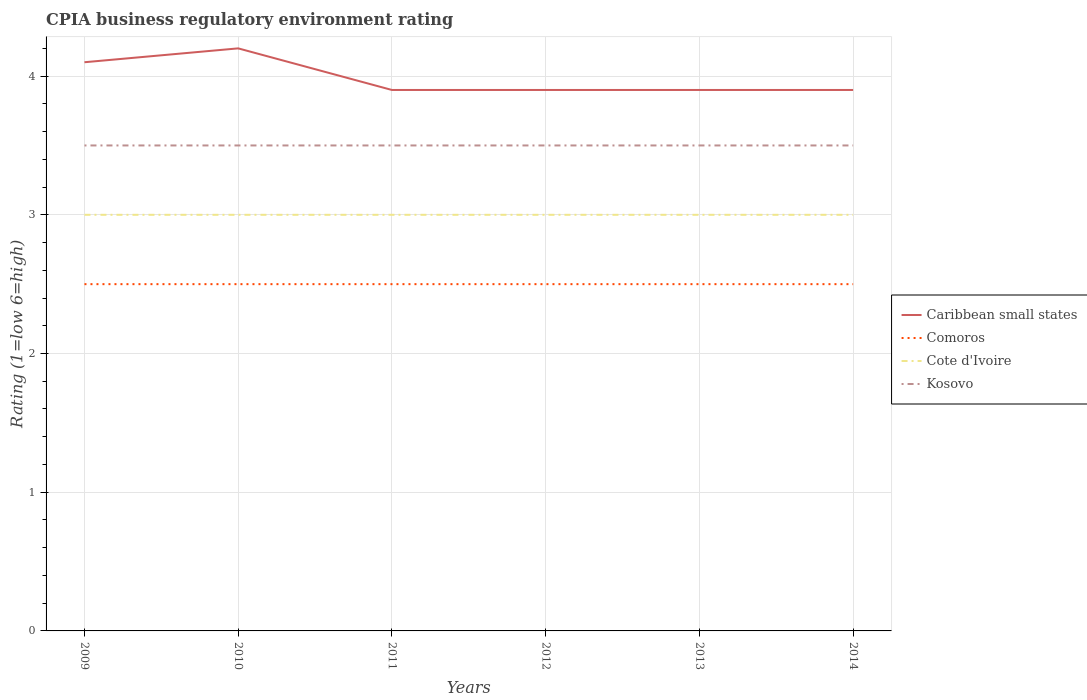Does the line corresponding to Kosovo intersect with the line corresponding to Caribbean small states?
Your response must be concise. No. Across all years, what is the maximum CPIA rating in Comoros?
Offer a terse response. 2.5. In which year was the CPIA rating in Kosovo maximum?
Your answer should be very brief. 2009. What is the difference between the highest and the lowest CPIA rating in Caribbean small states?
Your response must be concise. 2. How many lines are there?
Your answer should be very brief. 4. How many years are there in the graph?
Ensure brevity in your answer.  6. What is the difference between two consecutive major ticks on the Y-axis?
Give a very brief answer. 1. Does the graph contain any zero values?
Your answer should be very brief. No. How many legend labels are there?
Offer a very short reply. 4. What is the title of the graph?
Ensure brevity in your answer.  CPIA business regulatory environment rating. What is the Rating (1=low 6=high) of Cote d'Ivoire in 2009?
Your answer should be very brief. 3. What is the Rating (1=low 6=high) in Comoros in 2010?
Your answer should be compact. 2.5. What is the Rating (1=low 6=high) in Cote d'Ivoire in 2010?
Provide a succinct answer. 3. What is the Rating (1=low 6=high) in Caribbean small states in 2011?
Offer a very short reply. 3.9. What is the Rating (1=low 6=high) in Kosovo in 2011?
Ensure brevity in your answer.  3.5. What is the Rating (1=low 6=high) of Caribbean small states in 2012?
Offer a very short reply. 3.9. What is the Rating (1=low 6=high) in Comoros in 2012?
Give a very brief answer. 2.5. What is the Rating (1=low 6=high) of Kosovo in 2012?
Your answer should be compact. 3.5. What is the Rating (1=low 6=high) in Cote d'Ivoire in 2013?
Offer a very short reply. 3. What is the Rating (1=low 6=high) of Comoros in 2014?
Keep it short and to the point. 2.5. Across all years, what is the maximum Rating (1=low 6=high) in Caribbean small states?
Provide a succinct answer. 4.2. Across all years, what is the maximum Rating (1=low 6=high) in Comoros?
Provide a short and direct response. 2.5. Across all years, what is the maximum Rating (1=low 6=high) in Cote d'Ivoire?
Offer a terse response. 3. Across all years, what is the minimum Rating (1=low 6=high) in Caribbean small states?
Keep it short and to the point. 3.9. Across all years, what is the minimum Rating (1=low 6=high) of Comoros?
Your answer should be compact. 2.5. What is the total Rating (1=low 6=high) in Caribbean small states in the graph?
Your answer should be compact. 23.9. What is the total Rating (1=low 6=high) in Kosovo in the graph?
Ensure brevity in your answer.  21. What is the difference between the Rating (1=low 6=high) of Caribbean small states in 2009 and that in 2010?
Offer a very short reply. -0.1. What is the difference between the Rating (1=low 6=high) of Comoros in 2009 and that in 2010?
Ensure brevity in your answer.  0. What is the difference between the Rating (1=low 6=high) in Cote d'Ivoire in 2009 and that in 2010?
Your answer should be very brief. 0. What is the difference between the Rating (1=low 6=high) in Kosovo in 2009 and that in 2010?
Make the answer very short. 0. What is the difference between the Rating (1=low 6=high) in Cote d'Ivoire in 2009 and that in 2011?
Provide a short and direct response. 0. What is the difference between the Rating (1=low 6=high) of Kosovo in 2009 and that in 2011?
Keep it short and to the point. 0. What is the difference between the Rating (1=low 6=high) in Caribbean small states in 2009 and that in 2012?
Keep it short and to the point. 0.2. What is the difference between the Rating (1=low 6=high) in Cote d'Ivoire in 2009 and that in 2012?
Your response must be concise. 0. What is the difference between the Rating (1=low 6=high) in Caribbean small states in 2009 and that in 2014?
Make the answer very short. 0.2. What is the difference between the Rating (1=low 6=high) in Cote d'Ivoire in 2009 and that in 2014?
Your answer should be compact. 0. What is the difference between the Rating (1=low 6=high) in Cote d'Ivoire in 2010 and that in 2011?
Provide a short and direct response. 0. What is the difference between the Rating (1=low 6=high) in Kosovo in 2010 and that in 2011?
Your answer should be compact. 0. What is the difference between the Rating (1=low 6=high) in Caribbean small states in 2010 and that in 2012?
Your answer should be compact. 0.3. What is the difference between the Rating (1=low 6=high) of Comoros in 2010 and that in 2012?
Make the answer very short. 0. What is the difference between the Rating (1=low 6=high) of Cote d'Ivoire in 2010 and that in 2013?
Give a very brief answer. 0. What is the difference between the Rating (1=low 6=high) of Kosovo in 2010 and that in 2013?
Give a very brief answer. 0. What is the difference between the Rating (1=low 6=high) of Comoros in 2010 and that in 2014?
Provide a short and direct response. 0. What is the difference between the Rating (1=low 6=high) of Cote d'Ivoire in 2010 and that in 2014?
Offer a very short reply. 0. What is the difference between the Rating (1=low 6=high) of Kosovo in 2010 and that in 2014?
Your answer should be very brief. 0. What is the difference between the Rating (1=low 6=high) of Caribbean small states in 2011 and that in 2012?
Your answer should be very brief. 0. What is the difference between the Rating (1=low 6=high) in Cote d'Ivoire in 2011 and that in 2012?
Your answer should be very brief. 0. What is the difference between the Rating (1=low 6=high) of Kosovo in 2011 and that in 2012?
Offer a terse response. 0. What is the difference between the Rating (1=low 6=high) of Comoros in 2011 and that in 2013?
Ensure brevity in your answer.  0. What is the difference between the Rating (1=low 6=high) in Caribbean small states in 2011 and that in 2014?
Give a very brief answer. 0. What is the difference between the Rating (1=low 6=high) in Cote d'Ivoire in 2011 and that in 2014?
Provide a short and direct response. 0. What is the difference between the Rating (1=low 6=high) of Kosovo in 2011 and that in 2014?
Offer a terse response. 0. What is the difference between the Rating (1=low 6=high) of Cote d'Ivoire in 2012 and that in 2013?
Keep it short and to the point. 0. What is the difference between the Rating (1=low 6=high) of Kosovo in 2012 and that in 2013?
Ensure brevity in your answer.  0. What is the difference between the Rating (1=low 6=high) of Caribbean small states in 2012 and that in 2014?
Provide a succinct answer. 0. What is the difference between the Rating (1=low 6=high) of Cote d'Ivoire in 2012 and that in 2014?
Ensure brevity in your answer.  0. What is the difference between the Rating (1=low 6=high) of Kosovo in 2012 and that in 2014?
Your answer should be compact. 0. What is the difference between the Rating (1=low 6=high) of Caribbean small states in 2013 and that in 2014?
Give a very brief answer. 0. What is the difference between the Rating (1=low 6=high) of Comoros in 2013 and that in 2014?
Provide a succinct answer. 0. What is the difference between the Rating (1=low 6=high) of Cote d'Ivoire in 2013 and that in 2014?
Offer a terse response. 0. What is the difference between the Rating (1=low 6=high) of Caribbean small states in 2009 and the Rating (1=low 6=high) of Comoros in 2010?
Your answer should be compact. 1.6. What is the difference between the Rating (1=low 6=high) of Caribbean small states in 2009 and the Rating (1=low 6=high) of Cote d'Ivoire in 2010?
Offer a terse response. 1.1. What is the difference between the Rating (1=low 6=high) in Caribbean small states in 2009 and the Rating (1=low 6=high) in Kosovo in 2010?
Make the answer very short. 0.6. What is the difference between the Rating (1=low 6=high) of Comoros in 2009 and the Rating (1=low 6=high) of Cote d'Ivoire in 2010?
Your answer should be compact. -0.5. What is the difference between the Rating (1=low 6=high) in Comoros in 2009 and the Rating (1=low 6=high) in Kosovo in 2010?
Offer a terse response. -1. What is the difference between the Rating (1=low 6=high) in Caribbean small states in 2009 and the Rating (1=low 6=high) in Comoros in 2011?
Provide a short and direct response. 1.6. What is the difference between the Rating (1=low 6=high) of Caribbean small states in 2009 and the Rating (1=low 6=high) of Cote d'Ivoire in 2011?
Make the answer very short. 1.1. What is the difference between the Rating (1=low 6=high) in Caribbean small states in 2009 and the Rating (1=low 6=high) in Kosovo in 2011?
Provide a short and direct response. 0.6. What is the difference between the Rating (1=low 6=high) of Comoros in 2009 and the Rating (1=low 6=high) of Cote d'Ivoire in 2011?
Your answer should be compact. -0.5. What is the difference between the Rating (1=low 6=high) of Comoros in 2009 and the Rating (1=low 6=high) of Kosovo in 2011?
Give a very brief answer. -1. What is the difference between the Rating (1=low 6=high) in Cote d'Ivoire in 2009 and the Rating (1=low 6=high) in Kosovo in 2011?
Provide a succinct answer. -0.5. What is the difference between the Rating (1=low 6=high) in Caribbean small states in 2009 and the Rating (1=low 6=high) in Comoros in 2012?
Ensure brevity in your answer.  1.6. What is the difference between the Rating (1=low 6=high) of Caribbean small states in 2009 and the Rating (1=low 6=high) of Cote d'Ivoire in 2012?
Provide a succinct answer. 1.1. What is the difference between the Rating (1=low 6=high) in Comoros in 2009 and the Rating (1=low 6=high) in Kosovo in 2012?
Ensure brevity in your answer.  -1. What is the difference between the Rating (1=low 6=high) of Caribbean small states in 2009 and the Rating (1=low 6=high) of Comoros in 2013?
Ensure brevity in your answer.  1.6. What is the difference between the Rating (1=low 6=high) in Caribbean small states in 2009 and the Rating (1=low 6=high) in Cote d'Ivoire in 2013?
Provide a short and direct response. 1.1. What is the difference between the Rating (1=low 6=high) in Comoros in 2009 and the Rating (1=low 6=high) in Cote d'Ivoire in 2013?
Offer a very short reply. -0.5. What is the difference between the Rating (1=low 6=high) of Comoros in 2009 and the Rating (1=low 6=high) of Kosovo in 2013?
Keep it short and to the point. -1. What is the difference between the Rating (1=low 6=high) of Caribbean small states in 2009 and the Rating (1=low 6=high) of Comoros in 2014?
Your response must be concise. 1.6. What is the difference between the Rating (1=low 6=high) of Caribbean small states in 2009 and the Rating (1=low 6=high) of Kosovo in 2014?
Your answer should be very brief. 0.6. What is the difference between the Rating (1=low 6=high) of Comoros in 2009 and the Rating (1=low 6=high) of Cote d'Ivoire in 2014?
Your response must be concise. -0.5. What is the difference between the Rating (1=low 6=high) in Cote d'Ivoire in 2009 and the Rating (1=low 6=high) in Kosovo in 2014?
Offer a very short reply. -0.5. What is the difference between the Rating (1=low 6=high) of Caribbean small states in 2010 and the Rating (1=low 6=high) of Cote d'Ivoire in 2011?
Your response must be concise. 1.2. What is the difference between the Rating (1=low 6=high) of Caribbean small states in 2010 and the Rating (1=low 6=high) of Kosovo in 2011?
Offer a very short reply. 0.7. What is the difference between the Rating (1=low 6=high) in Comoros in 2010 and the Rating (1=low 6=high) in Cote d'Ivoire in 2011?
Make the answer very short. -0.5. What is the difference between the Rating (1=low 6=high) of Comoros in 2010 and the Rating (1=low 6=high) of Kosovo in 2011?
Your response must be concise. -1. What is the difference between the Rating (1=low 6=high) in Caribbean small states in 2010 and the Rating (1=low 6=high) in Comoros in 2012?
Your answer should be compact. 1.7. What is the difference between the Rating (1=low 6=high) of Caribbean small states in 2010 and the Rating (1=low 6=high) of Kosovo in 2012?
Make the answer very short. 0.7. What is the difference between the Rating (1=low 6=high) of Comoros in 2010 and the Rating (1=low 6=high) of Cote d'Ivoire in 2012?
Give a very brief answer. -0.5. What is the difference between the Rating (1=low 6=high) of Comoros in 2010 and the Rating (1=low 6=high) of Kosovo in 2012?
Your answer should be compact. -1. What is the difference between the Rating (1=low 6=high) of Caribbean small states in 2010 and the Rating (1=low 6=high) of Cote d'Ivoire in 2013?
Keep it short and to the point. 1.2. What is the difference between the Rating (1=low 6=high) in Comoros in 2010 and the Rating (1=low 6=high) in Cote d'Ivoire in 2013?
Make the answer very short. -0.5. What is the difference between the Rating (1=low 6=high) in Caribbean small states in 2010 and the Rating (1=low 6=high) in Cote d'Ivoire in 2014?
Ensure brevity in your answer.  1.2. What is the difference between the Rating (1=low 6=high) of Caribbean small states in 2011 and the Rating (1=low 6=high) of Comoros in 2012?
Make the answer very short. 1.4. What is the difference between the Rating (1=low 6=high) in Caribbean small states in 2011 and the Rating (1=low 6=high) in Cote d'Ivoire in 2012?
Provide a succinct answer. 0.9. What is the difference between the Rating (1=low 6=high) in Caribbean small states in 2011 and the Rating (1=low 6=high) in Kosovo in 2012?
Your answer should be compact. 0.4. What is the difference between the Rating (1=low 6=high) of Cote d'Ivoire in 2011 and the Rating (1=low 6=high) of Kosovo in 2012?
Provide a short and direct response. -0.5. What is the difference between the Rating (1=low 6=high) of Caribbean small states in 2011 and the Rating (1=low 6=high) of Kosovo in 2013?
Give a very brief answer. 0.4. What is the difference between the Rating (1=low 6=high) in Comoros in 2011 and the Rating (1=low 6=high) in Cote d'Ivoire in 2013?
Make the answer very short. -0.5. What is the difference between the Rating (1=low 6=high) in Comoros in 2011 and the Rating (1=low 6=high) in Kosovo in 2013?
Keep it short and to the point. -1. What is the difference between the Rating (1=low 6=high) of Cote d'Ivoire in 2011 and the Rating (1=low 6=high) of Kosovo in 2013?
Offer a terse response. -0.5. What is the difference between the Rating (1=low 6=high) of Caribbean small states in 2011 and the Rating (1=low 6=high) of Kosovo in 2014?
Your response must be concise. 0.4. What is the difference between the Rating (1=low 6=high) of Comoros in 2011 and the Rating (1=low 6=high) of Cote d'Ivoire in 2014?
Provide a short and direct response. -0.5. What is the difference between the Rating (1=low 6=high) of Cote d'Ivoire in 2011 and the Rating (1=low 6=high) of Kosovo in 2014?
Provide a short and direct response. -0.5. What is the difference between the Rating (1=low 6=high) in Caribbean small states in 2012 and the Rating (1=low 6=high) in Comoros in 2013?
Offer a terse response. 1.4. What is the difference between the Rating (1=low 6=high) of Caribbean small states in 2012 and the Rating (1=low 6=high) of Cote d'Ivoire in 2013?
Provide a succinct answer. 0.9. What is the difference between the Rating (1=low 6=high) in Cote d'Ivoire in 2012 and the Rating (1=low 6=high) in Kosovo in 2013?
Provide a succinct answer. -0.5. What is the difference between the Rating (1=low 6=high) in Caribbean small states in 2012 and the Rating (1=low 6=high) in Cote d'Ivoire in 2014?
Give a very brief answer. 0.9. What is the difference between the Rating (1=low 6=high) in Caribbean small states in 2013 and the Rating (1=low 6=high) in Comoros in 2014?
Provide a succinct answer. 1.4. What is the difference between the Rating (1=low 6=high) in Caribbean small states in 2013 and the Rating (1=low 6=high) in Kosovo in 2014?
Offer a very short reply. 0.4. What is the difference between the Rating (1=low 6=high) in Comoros in 2013 and the Rating (1=low 6=high) in Cote d'Ivoire in 2014?
Ensure brevity in your answer.  -0.5. What is the difference between the Rating (1=low 6=high) of Comoros in 2013 and the Rating (1=low 6=high) of Kosovo in 2014?
Ensure brevity in your answer.  -1. What is the difference between the Rating (1=low 6=high) of Cote d'Ivoire in 2013 and the Rating (1=low 6=high) of Kosovo in 2014?
Your response must be concise. -0.5. What is the average Rating (1=low 6=high) in Caribbean small states per year?
Make the answer very short. 3.98. What is the average Rating (1=low 6=high) in Comoros per year?
Your response must be concise. 2.5. What is the average Rating (1=low 6=high) of Cote d'Ivoire per year?
Keep it short and to the point. 3. In the year 2009, what is the difference between the Rating (1=low 6=high) in Caribbean small states and Rating (1=low 6=high) in Kosovo?
Your response must be concise. 0.6. In the year 2009, what is the difference between the Rating (1=low 6=high) of Comoros and Rating (1=low 6=high) of Cote d'Ivoire?
Keep it short and to the point. -0.5. In the year 2009, what is the difference between the Rating (1=low 6=high) in Cote d'Ivoire and Rating (1=low 6=high) in Kosovo?
Your response must be concise. -0.5. In the year 2010, what is the difference between the Rating (1=low 6=high) of Comoros and Rating (1=low 6=high) of Cote d'Ivoire?
Give a very brief answer. -0.5. In the year 2010, what is the difference between the Rating (1=low 6=high) of Cote d'Ivoire and Rating (1=low 6=high) of Kosovo?
Offer a terse response. -0.5. In the year 2011, what is the difference between the Rating (1=low 6=high) of Caribbean small states and Rating (1=low 6=high) of Comoros?
Provide a short and direct response. 1.4. In the year 2011, what is the difference between the Rating (1=low 6=high) of Caribbean small states and Rating (1=low 6=high) of Cote d'Ivoire?
Provide a short and direct response. 0.9. In the year 2011, what is the difference between the Rating (1=low 6=high) in Caribbean small states and Rating (1=low 6=high) in Kosovo?
Offer a very short reply. 0.4. In the year 2011, what is the difference between the Rating (1=low 6=high) of Comoros and Rating (1=low 6=high) of Cote d'Ivoire?
Your answer should be compact. -0.5. In the year 2011, what is the difference between the Rating (1=low 6=high) of Comoros and Rating (1=low 6=high) of Kosovo?
Your answer should be very brief. -1. In the year 2012, what is the difference between the Rating (1=low 6=high) in Caribbean small states and Rating (1=low 6=high) in Comoros?
Your answer should be compact. 1.4. In the year 2012, what is the difference between the Rating (1=low 6=high) in Caribbean small states and Rating (1=low 6=high) in Kosovo?
Offer a terse response. 0.4. In the year 2013, what is the difference between the Rating (1=low 6=high) in Caribbean small states and Rating (1=low 6=high) in Comoros?
Your response must be concise. 1.4. In the year 2013, what is the difference between the Rating (1=low 6=high) of Caribbean small states and Rating (1=low 6=high) of Cote d'Ivoire?
Give a very brief answer. 0.9. In the year 2014, what is the difference between the Rating (1=low 6=high) of Caribbean small states and Rating (1=low 6=high) of Comoros?
Give a very brief answer. 1.4. In the year 2014, what is the difference between the Rating (1=low 6=high) in Caribbean small states and Rating (1=low 6=high) in Cote d'Ivoire?
Offer a terse response. 0.9. In the year 2014, what is the difference between the Rating (1=low 6=high) in Caribbean small states and Rating (1=low 6=high) in Kosovo?
Your response must be concise. 0.4. In the year 2014, what is the difference between the Rating (1=low 6=high) of Comoros and Rating (1=low 6=high) of Cote d'Ivoire?
Make the answer very short. -0.5. What is the ratio of the Rating (1=low 6=high) in Caribbean small states in 2009 to that in 2010?
Provide a short and direct response. 0.98. What is the ratio of the Rating (1=low 6=high) of Caribbean small states in 2009 to that in 2011?
Your answer should be compact. 1.05. What is the ratio of the Rating (1=low 6=high) of Cote d'Ivoire in 2009 to that in 2011?
Offer a terse response. 1. What is the ratio of the Rating (1=low 6=high) of Kosovo in 2009 to that in 2011?
Your answer should be compact. 1. What is the ratio of the Rating (1=low 6=high) of Caribbean small states in 2009 to that in 2012?
Offer a very short reply. 1.05. What is the ratio of the Rating (1=low 6=high) of Cote d'Ivoire in 2009 to that in 2012?
Keep it short and to the point. 1. What is the ratio of the Rating (1=low 6=high) in Caribbean small states in 2009 to that in 2013?
Your answer should be very brief. 1.05. What is the ratio of the Rating (1=low 6=high) of Comoros in 2009 to that in 2013?
Provide a short and direct response. 1. What is the ratio of the Rating (1=low 6=high) in Cote d'Ivoire in 2009 to that in 2013?
Your answer should be very brief. 1. What is the ratio of the Rating (1=low 6=high) in Kosovo in 2009 to that in 2013?
Your answer should be compact. 1. What is the ratio of the Rating (1=low 6=high) in Caribbean small states in 2009 to that in 2014?
Your answer should be very brief. 1.05. What is the ratio of the Rating (1=low 6=high) in Comoros in 2009 to that in 2014?
Your answer should be compact. 1. What is the ratio of the Rating (1=low 6=high) of Caribbean small states in 2010 to that in 2011?
Provide a succinct answer. 1.08. What is the ratio of the Rating (1=low 6=high) of Comoros in 2010 to that in 2011?
Offer a terse response. 1. What is the ratio of the Rating (1=low 6=high) in Kosovo in 2010 to that in 2011?
Your answer should be compact. 1. What is the ratio of the Rating (1=low 6=high) in Caribbean small states in 2010 to that in 2012?
Make the answer very short. 1.08. What is the ratio of the Rating (1=low 6=high) of Kosovo in 2010 to that in 2012?
Your answer should be very brief. 1. What is the ratio of the Rating (1=low 6=high) of Comoros in 2010 to that in 2013?
Offer a terse response. 1. What is the ratio of the Rating (1=low 6=high) in Kosovo in 2010 to that in 2013?
Keep it short and to the point. 1. What is the ratio of the Rating (1=low 6=high) in Caribbean small states in 2010 to that in 2014?
Provide a short and direct response. 1.08. What is the ratio of the Rating (1=low 6=high) of Comoros in 2010 to that in 2014?
Make the answer very short. 1. What is the ratio of the Rating (1=low 6=high) of Cote d'Ivoire in 2010 to that in 2014?
Make the answer very short. 1. What is the ratio of the Rating (1=low 6=high) of Kosovo in 2010 to that in 2014?
Ensure brevity in your answer.  1. What is the ratio of the Rating (1=low 6=high) in Cote d'Ivoire in 2011 to that in 2012?
Offer a terse response. 1. What is the ratio of the Rating (1=low 6=high) in Kosovo in 2011 to that in 2012?
Offer a terse response. 1. What is the ratio of the Rating (1=low 6=high) of Comoros in 2011 to that in 2013?
Your answer should be very brief. 1. What is the ratio of the Rating (1=low 6=high) in Kosovo in 2011 to that in 2013?
Offer a terse response. 1. What is the ratio of the Rating (1=low 6=high) of Caribbean small states in 2011 to that in 2014?
Keep it short and to the point. 1. What is the ratio of the Rating (1=low 6=high) in Comoros in 2011 to that in 2014?
Your answer should be very brief. 1. What is the ratio of the Rating (1=low 6=high) of Cote d'Ivoire in 2012 to that in 2013?
Your answer should be very brief. 1. What is the ratio of the Rating (1=low 6=high) of Comoros in 2012 to that in 2014?
Give a very brief answer. 1. What is the ratio of the Rating (1=low 6=high) in Cote d'Ivoire in 2012 to that in 2014?
Ensure brevity in your answer.  1. What is the ratio of the Rating (1=low 6=high) in Kosovo in 2012 to that in 2014?
Your response must be concise. 1. What is the ratio of the Rating (1=low 6=high) of Cote d'Ivoire in 2013 to that in 2014?
Give a very brief answer. 1. What is the difference between the highest and the second highest Rating (1=low 6=high) of Caribbean small states?
Offer a terse response. 0.1. What is the difference between the highest and the second highest Rating (1=low 6=high) in Kosovo?
Offer a very short reply. 0. What is the difference between the highest and the lowest Rating (1=low 6=high) of Cote d'Ivoire?
Give a very brief answer. 0. What is the difference between the highest and the lowest Rating (1=low 6=high) of Kosovo?
Your answer should be very brief. 0. 